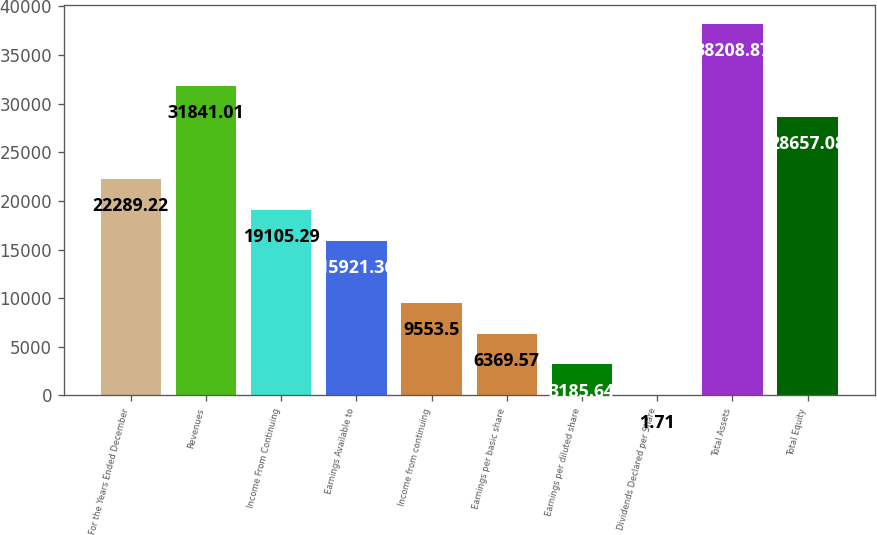<chart> <loc_0><loc_0><loc_500><loc_500><bar_chart><fcel>For the Years Ended December<fcel>Revenues<fcel>Income From Continuing<fcel>Earnings Available to<fcel>Income from continuing<fcel>Earnings per basic share<fcel>Earnings per diluted share<fcel>Dividends Declared per Share<fcel>Total Assets<fcel>Total Equity<nl><fcel>22289.2<fcel>31841<fcel>19105.3<fcel>15921.4<fcel>9553.5<fcel>6369.57<fcel>3185.64<fcel>1.71<fcel>38208.9<fcel>28657.1<nl></chart> 